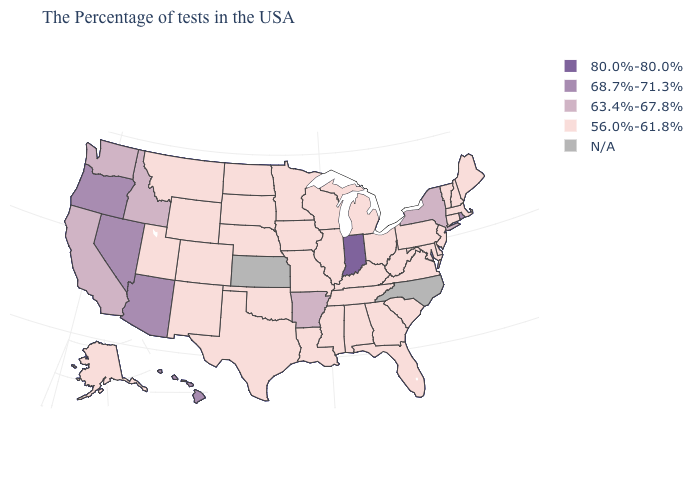Which states have the highest value in the USA?
Write a very short answer. Indiana. What is the value of Louisiana?
Write a very short answer. 56.0%-61.8%. Name the states that have a value in the range 56.0%-61.8%?
Write a very short answer. Maine, Massachusetts, New Hampshire, Vermont, Connecticut, New Jersey, Delaware, Maryland, Pennsylvania, Virginia, South Carolina, West Virginia, Ohio, Florida, Georgia, Michigan, Kentucky, Alabama, Tennessee, Wisconsin, Illinois, Mississippi, Louisiana, Missouri, Minnesota, Iowa, Nebraska, Oklahoma, Texas, South Dakota, North Dakota, Wyoming, Colorado, New Mexico, Utah, Montana, Alaska. Does South Carolina have the lowest value in the USA?
Short answer required. Yes. What is the lowest value in the USA?
Short answer required. 56.0%-61.8%. What is the value of New Hampshire?
Short answer required. 56.0%-61.8%. What is the value of Minnesota?
Quick response, please. 56.0%-61.8%. Name the states that have a value in the range N/A?
Short answer required. North Carolina, Kansas. Name the states that have a value in the range 80.0%-80.0%?
Concise answer only. Indiana. What is the value of Vermont?
Short answer required. 56.0%-61.8%. Is the legend a continuous bar?
Give a very brief answer. No. Does California have the highest value in the West?
Concise answer only. No. What is the value of New Jersey?
Keep it brief. 56.0%-61.8%. Which states have the lowest value in the USA?
Answer briefly. Maine, Massachusetts, New Hampshire, Vermont, Connecticut, New Jersey, Delaware, Maryland, Pennsylvania, Virginia, South Carolina, West Virginia, Ohio, Florida, Georgia, Michigan, Kentucky, Alabama, Tennessee, Wisconsin, Illinois, Mississippi, Louisiana, Missouri, Minnesota, Iowa, Nebraska, Oklahoma, Texas, South Dakota, North Dakota, Wyoming, Colorado, New Mexico, Utah, Montana, Alaska. What is the value of Colorado?
Write a very short answer. 56.0%-61.8%. 